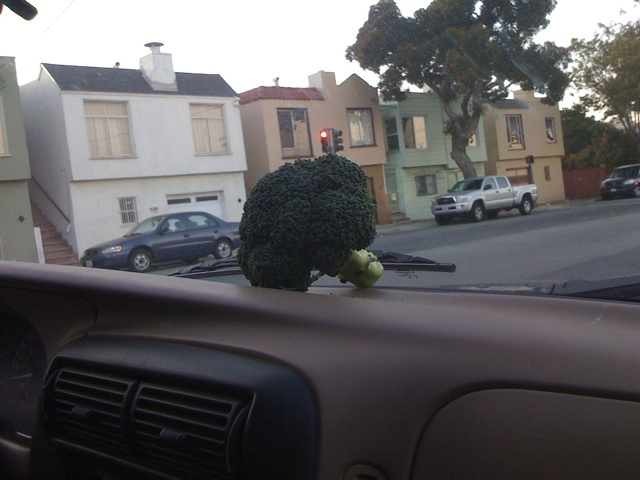<image>Urban or suburban? It is ambiguous whether the scene is urban or suburban. Urban or suburban? I don't know if it is urban or suburban. It can be both urban and suburban. 